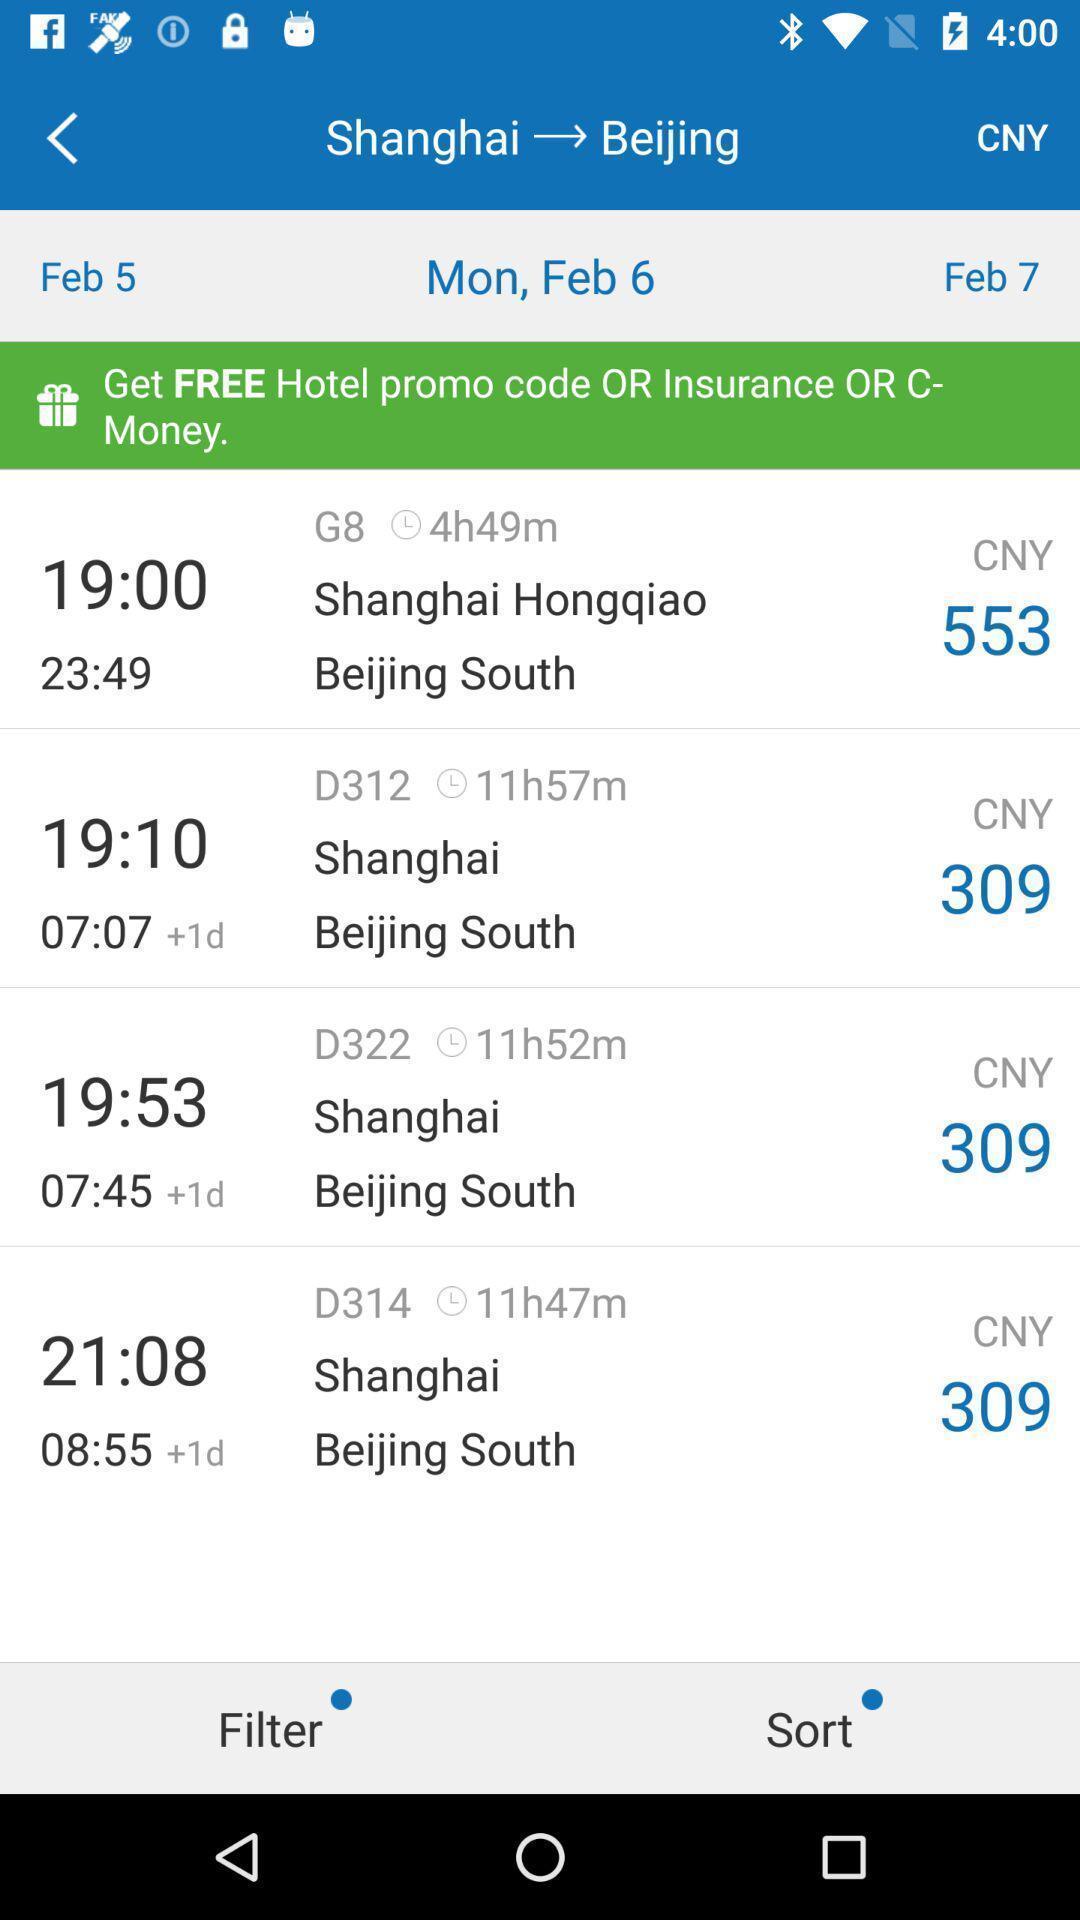What can you discern from this picture? Screen displaying list of hotels information in a travelling application. 